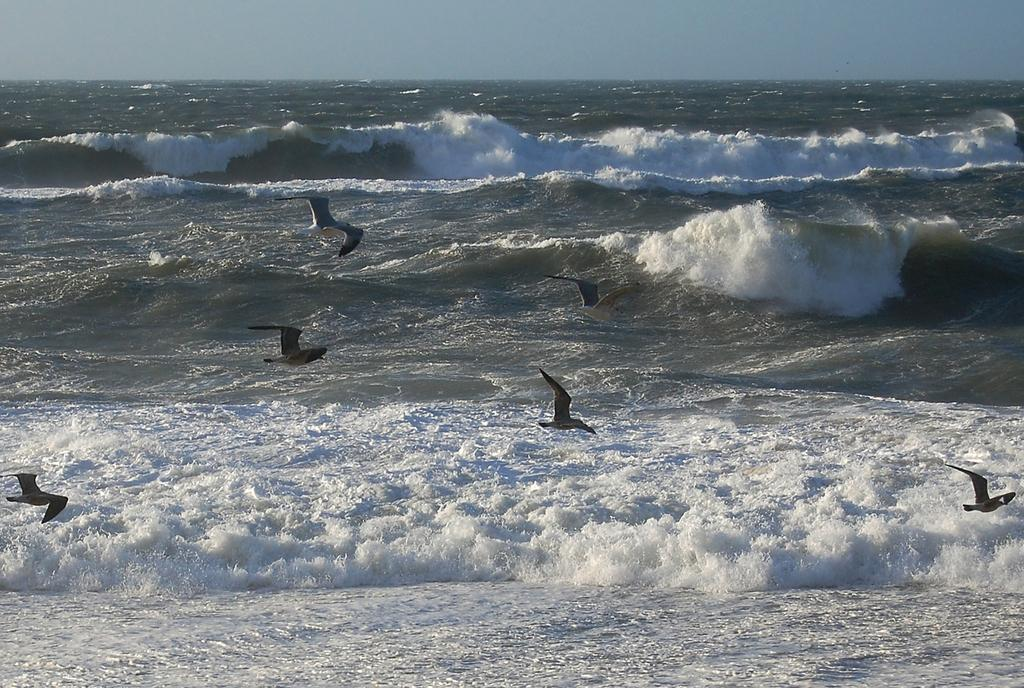What type of animals can be seen in the image? There are birds in the image. What natural feature is depicted in the image? The image depicts a sea. What can be seen in the background of the image? There is sky visible in the background of the image. How many spiders are crawling on the birds in the image? There are no spiders present in the image; it features birds and a sea. What type of jewelry is worn by the birds in the image? There is no jewelry, such as a locket, present in the image. 